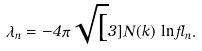Convert formula to latex. <formula><loc_0><loc_0><loc_500><loc_500>\lambda _ { n } = - 4 \pi \sqrt { [ } 3 ] { N ( k ) } \, \ln \Lambda _ { n } .</formula> 